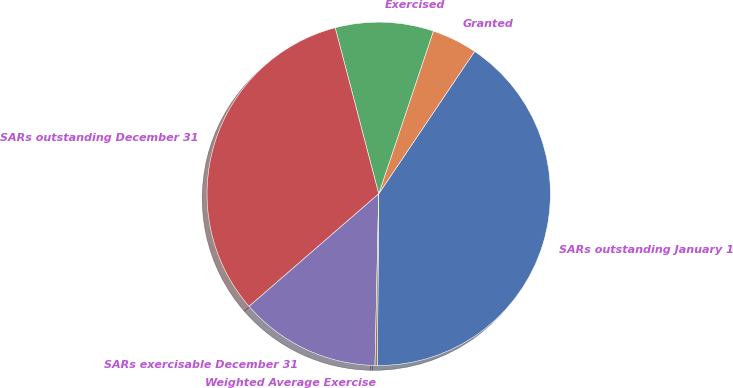Convert chart. <chart><loc_0><loc_0><loc_500><loc_500><pie_chart><fcel>SARs outstanding January 1<fcel>Granted<fcel>Exercised<fcel>SARs outstanding December 31<fcel>SARs exercisable December 31<fcel>Weighted Average Exercise<nl><fcel>40.7%<fcel>4.27%<fcel>9.24%<fcel>32.3%<fcel>13.28%<fcel>0.22%<nl></chart> 